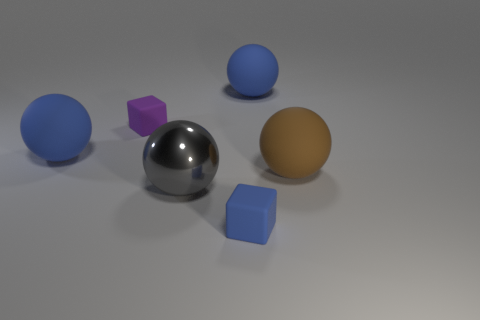Is there a metallic object of the same size as the blue matte cube?
Keep it short and to the point. No. Is the size of the blue matte object that is on the left side of the small blue matte object the same as the blue matte ball on the right side of the big gray metal ball?
Keep it short and to the point. Yes. What is the shape of the small rubber thing behind the tiny thing in front of the big gray sphere?
Ensure brevity in your answer.  Cube. There is a tiny purple matte thing; what number of matte objects are in front of it?
Ensure brevity in your answer.  3. There is a tiny object that is the same material as the blue block; what is its color?
Your answer should be very brief. Purple. Do the blue cube and the ball to the left of the gray thing have the same size?
Give a very brief answer. No. There is a rubber block that is in front of the big rubber ball that is on the left side of the small thing that is left of the gray object; how big is it?
Keep it short and to the point. Small. How many matte things are either blue balls or purple blocks?
Offer a terse response. 3. What is the color of the cube that is on the right side of the tiny purple matte thing?
Keep it short and to the point. Blue. What shape is the brown object that is the same size as the metallic ball?
Offer a terse response. Sphere. 